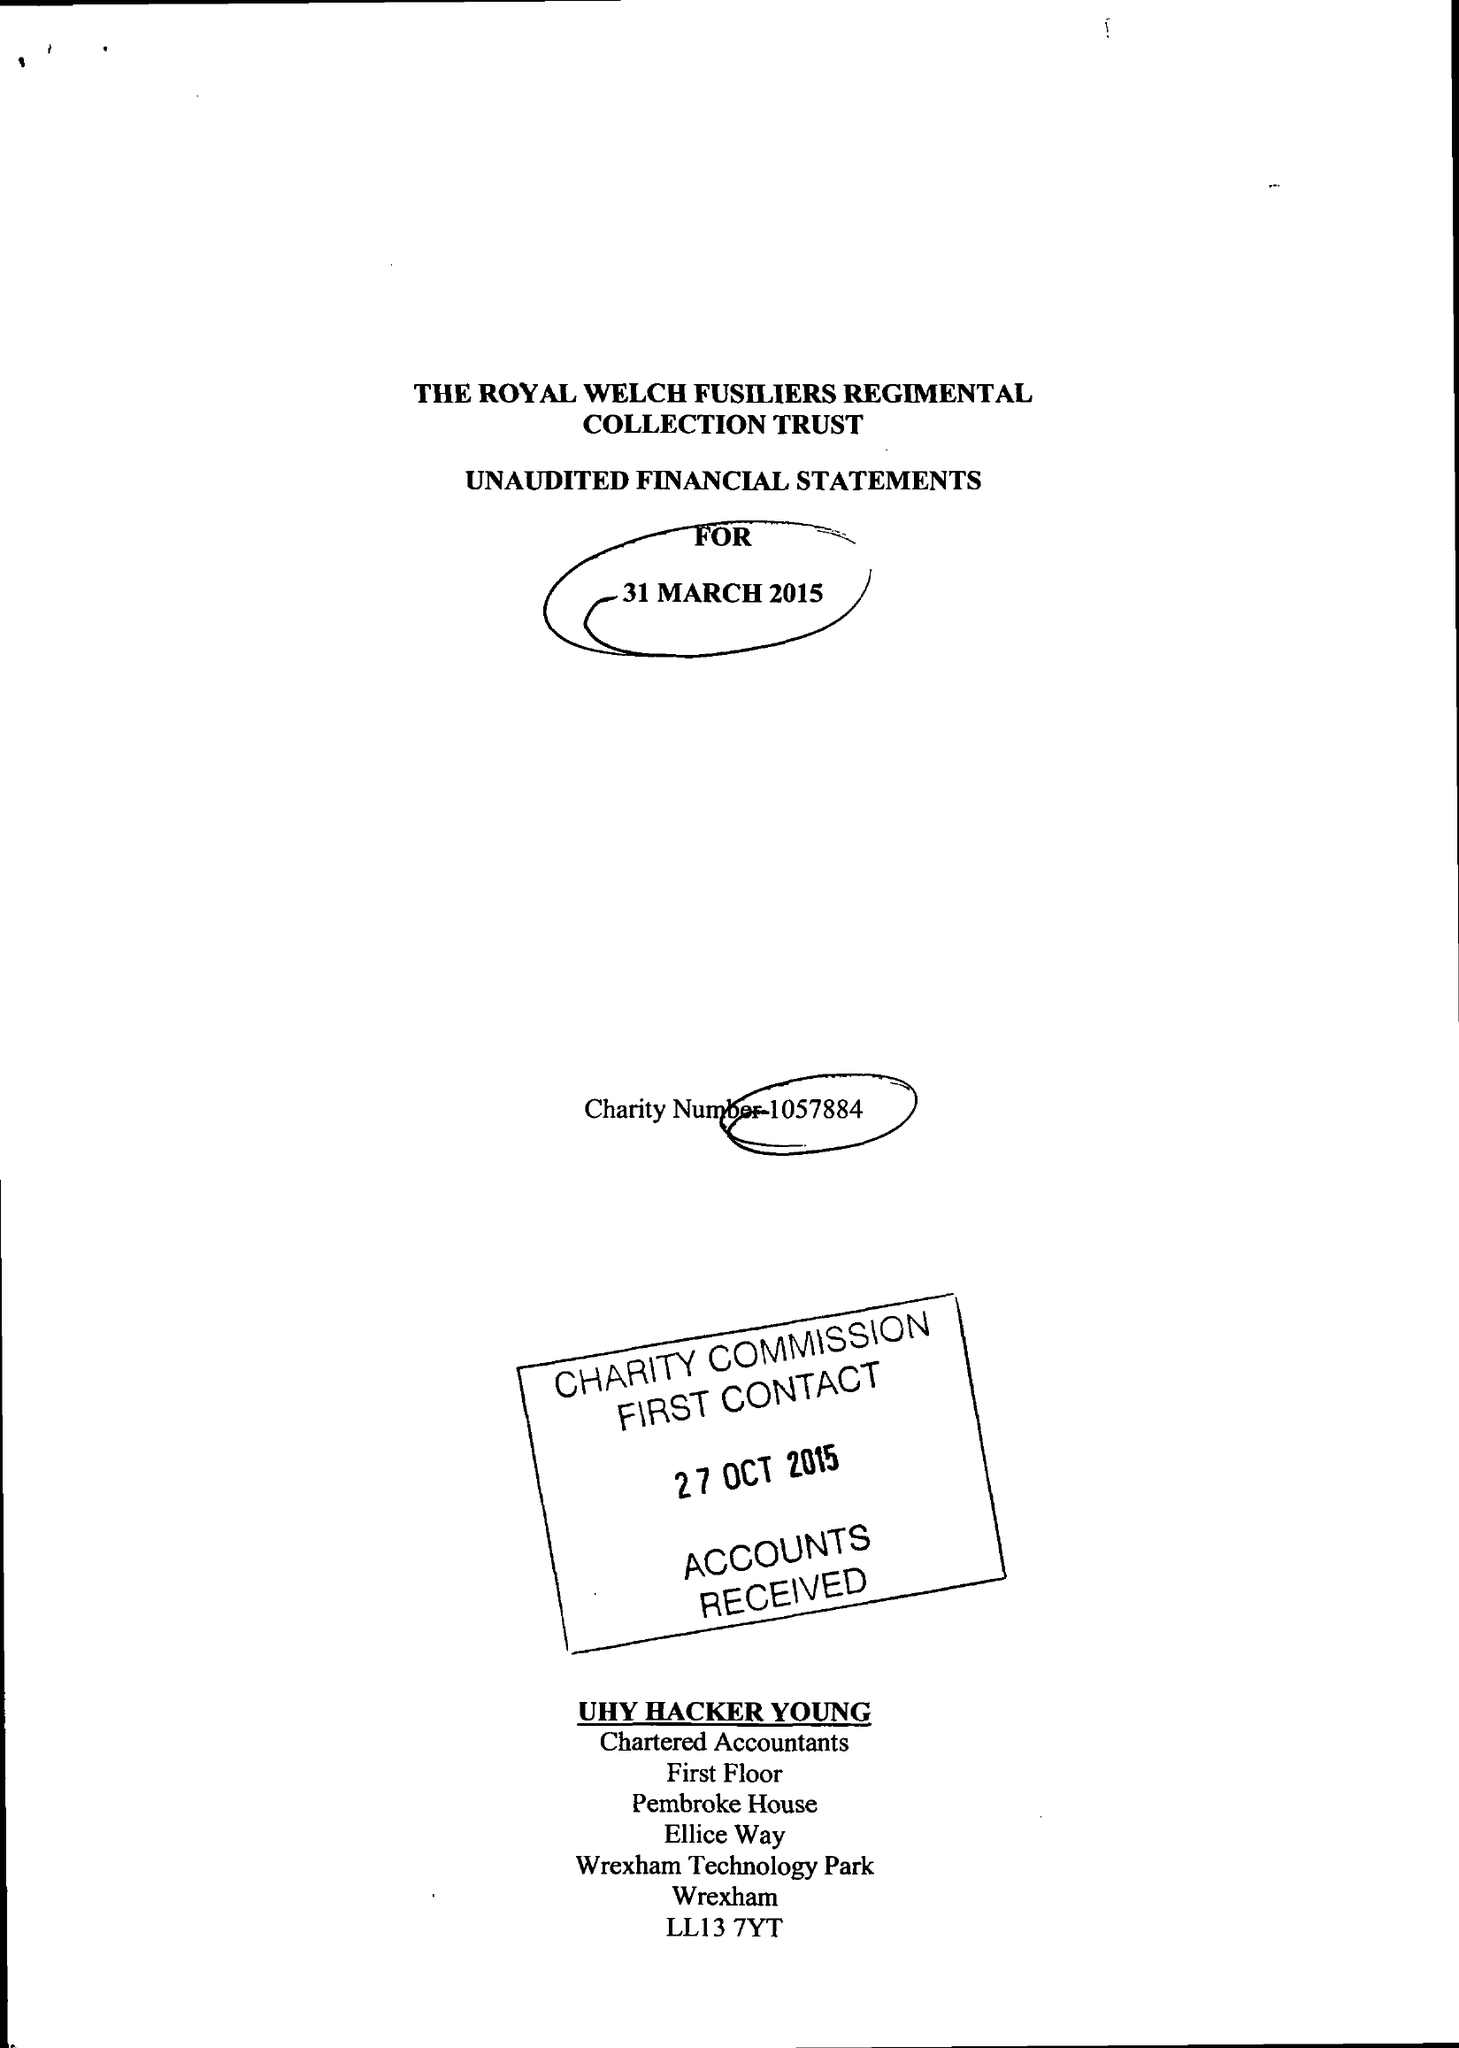What is the value for the income_annually_in_british_pounds?
Answer the question using a single word or phrase. 200188.00 